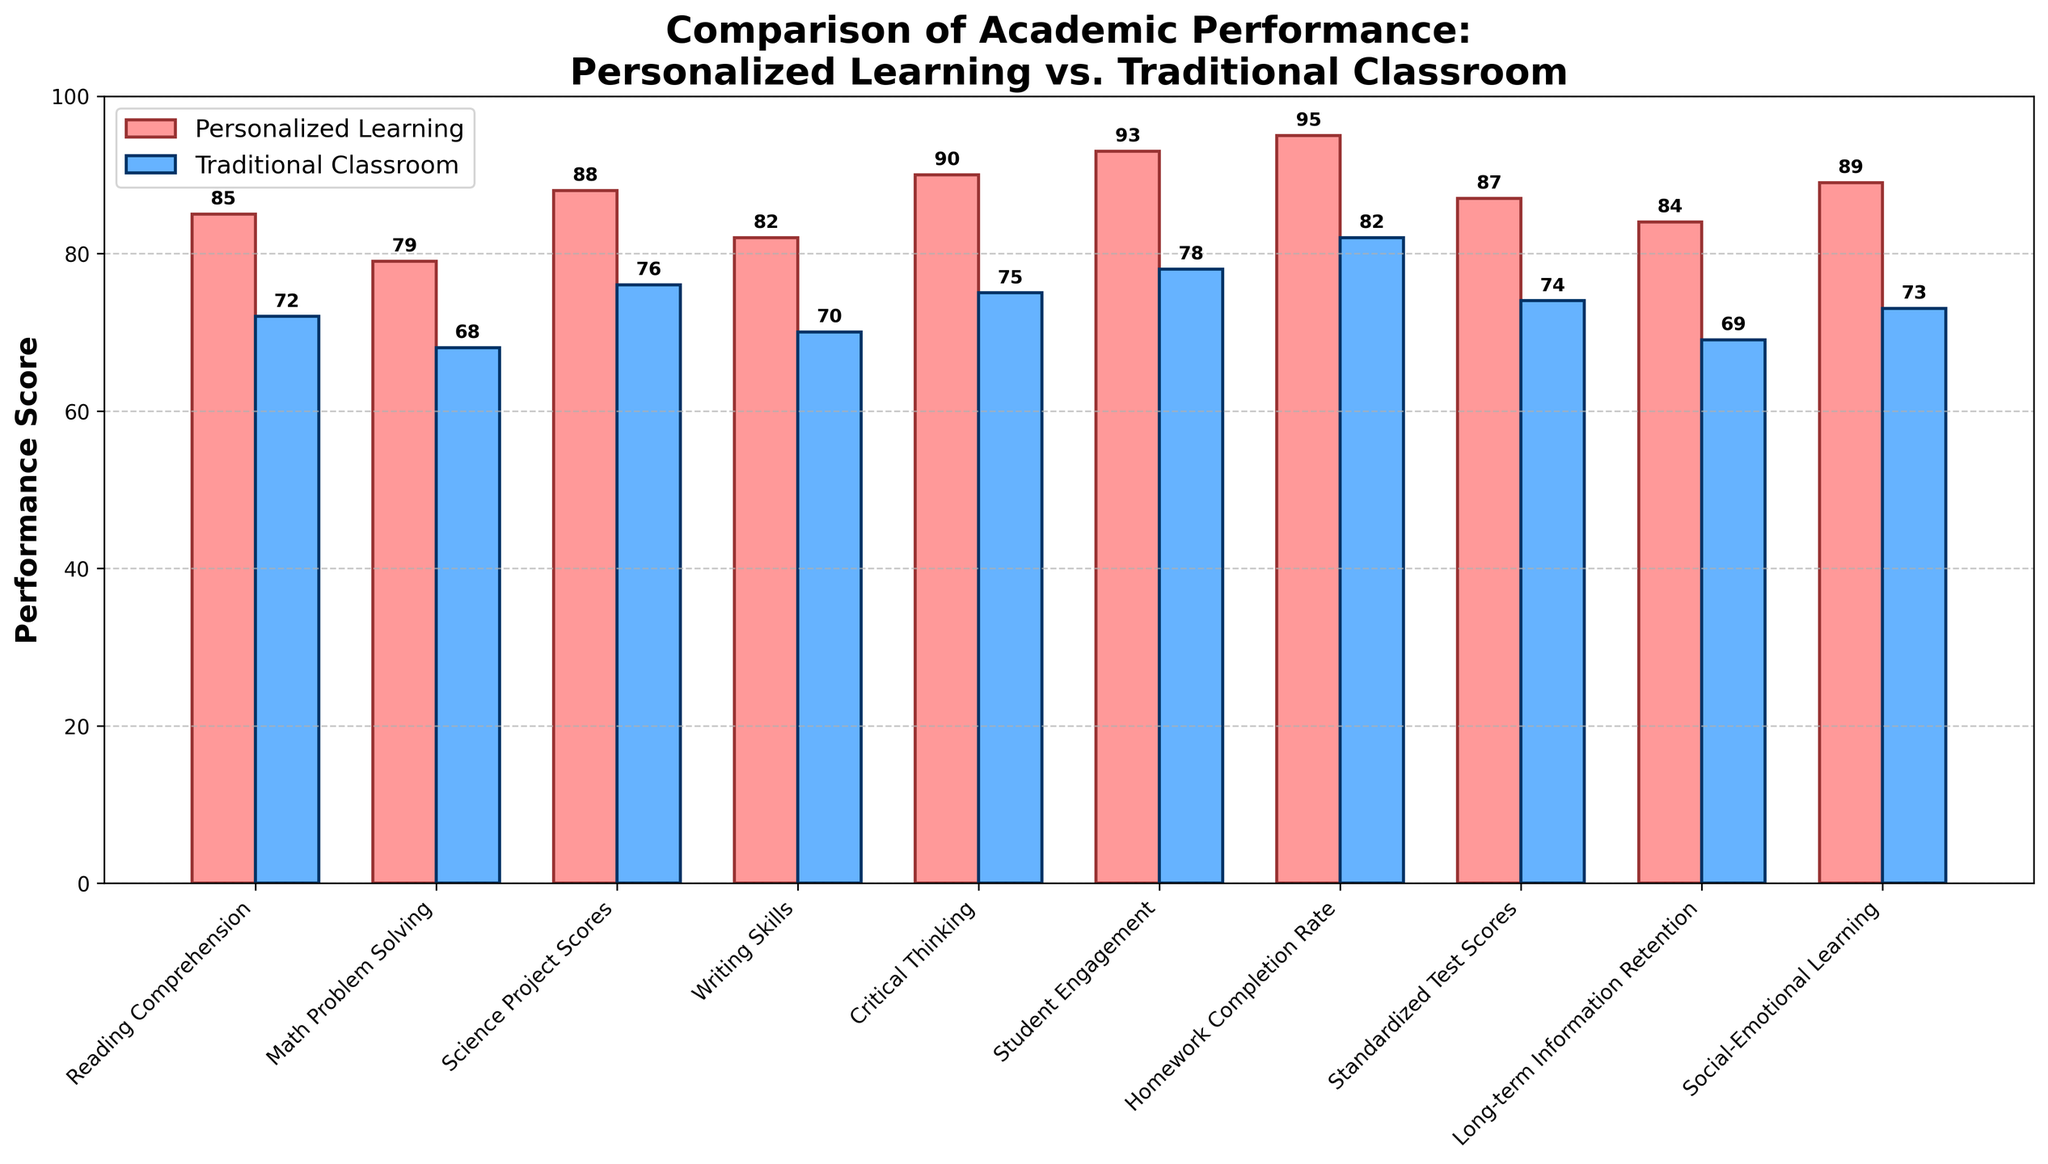What's the difference in Reading Comprehension scores between personalized learning and traditional classrooms? To find the difference, subtract the score of the traditional classroom from the score of personalized learning: 85 - 72 = 13.
Answer: 13 Which subject shows the highest performance score in personalized learning? By scanning the bars for personalized learning, we can see that the highest bar is for Student Engagement at 93.
Answer: Student Engagement Which subject has the smallest difference in performance scores between personalized learning and traditional classrooms? To find the smallest difference, calculate each difference and compare: Reading Comprehension (13), Math Problem Solving (11), Science Project Scores (12), Writing Skills (12), Critical Thinking (15), Student Engagement (15), Homework Completion Rate (13), Standardized Test Scores (13), Long-term Information Retention (15), Social-Emotional Learning (16). The smallest difference is 11 for Math Problem Solving.
Answer: Math Problem Solving What is the average score of traditional classroom performance across all subjects? Sum all traditional classroom scores and divide by the number of subjects: (72 + 68 + 76 + 70 + 75 + 78 + 82 + 74 + 69 + 73) / 10 = 73.7.
Answer: 73.7 Is the Homework Completion Rate higher in personalized learning or traditional classrooms? Compare the heights of the bars for Homework Completion Rate: 95 (personalized learning) vs. 82 (traditional classroom). The bar for personalized learning is higher.
Answer: Personalized Learning By how much does Critical Thinking in personalized learning exceed traditional classrooms? Calculate the difference: 90 - 75 = 15.
Answer: 15 Overall, are personalized learning scores consistently higher than traditional classroom scores across all subjects? Compare each pair of bars for every subject, and note that in each case, the personalized learning bar is higher.
Answer: Yes What is the total score for Science Project Scores, Writing Skills, and Critical Thinking in personalized learning? Sum the scores for these subjects in personalized learning: 88 + 82 + 90 = 260.
Answer: 260 Which subject has the biggest gap in performance between personalized learning and traditional classrooms? Calculate the difference for each subject: Reading Comprehension (13), Math Problem Solving (11), Science Project Scores (12), Writing Skills (12), Critical Thinking (15), Student Engagement (15), Homework Completion Rate (13), Standardized Test Scores (13), Long-term Information Retention (15), Social-Emotional Learning (16). The biggest gap is 16 in Social-Emotional Learning.
Answer: Social-Emotional Learning What's the trend of Student Engagement between personalized learning and traditional classrooms? Compare the heights of the bars for Student Engagement: 93 (personalized learning) vs. 78 (traditional classroom). The trend shows significantly higher engagement in personalized learning.
Answer: Higher in Personalized Learning 